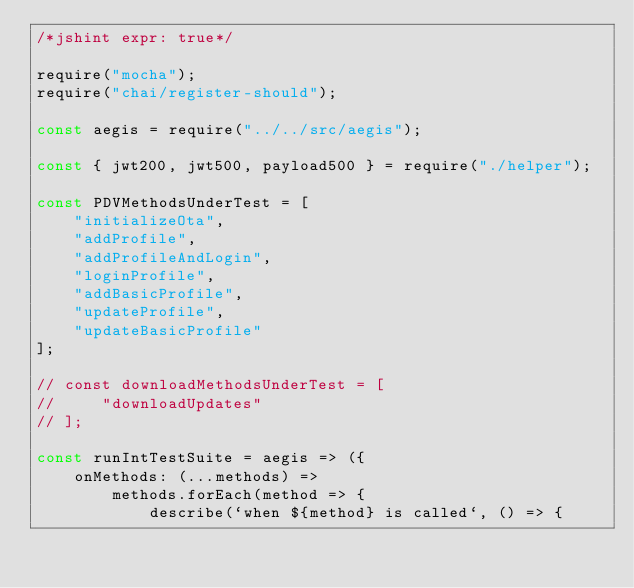Convert code to text. <code><loc_0><loc_0><loc_500><loc_500><_JavaScript_>/*jshint expr: true*/

require("mocha");
require("chai/register-should");

const aegis = require("../../src/aegis");

const { jwt200, jwt500, payload500 } = require("./helper");

const PDVMethodsUnderTest = [
    "initializeOta",
    "addProfile",
    "addProfileAndLogin",
    "loginProfile",
    "addBasicProfile",
    "updateProfile",
    "updateBasicProfile"
];

// const downloadMethodsUnderTest = [
//     "downloadUpdates"
// ];

const runIntTestSuite = aegis => ({
    onMethods: (...methods) =>
        methods.forEach(method => {
            describe(`when ${method} is called`, () => {</code> 